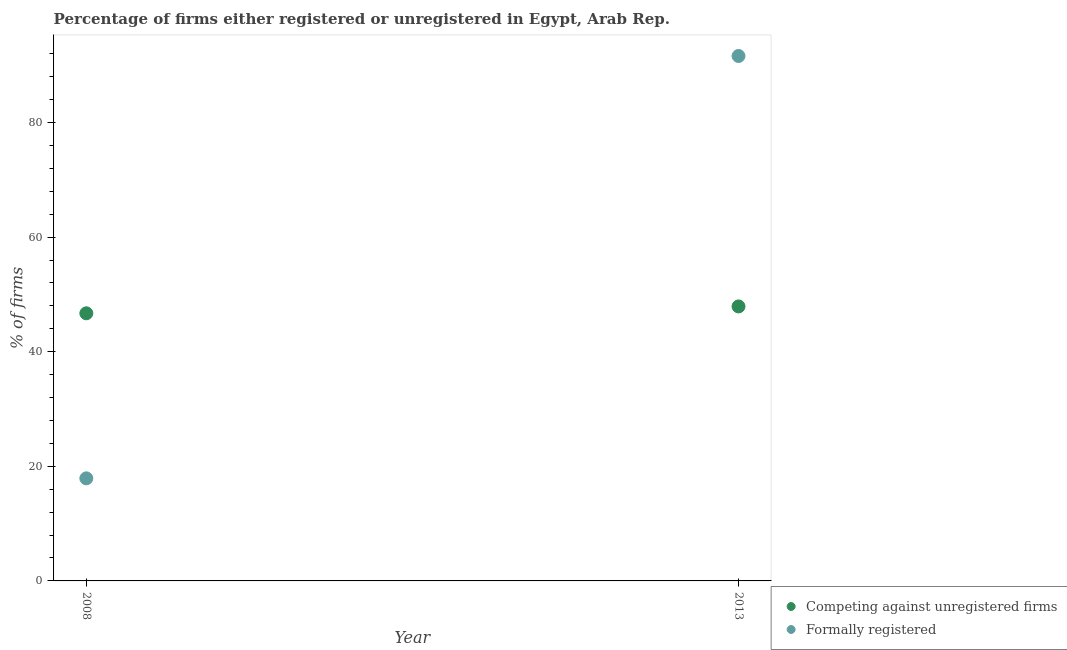Is the number of dotlines equal to the number of legend labels?
Offer a very short reply. Yes. What is the percentage of formally registered firms in 2013?
Your answer should be very brief. 91.6. Across all years, what is the maximum percentage of formally registered firms?
Provide a short and direct response. 91.6. Across all years, what is the minimum percentage of registered firms?
Give a very brief answer. 46.7. What is the total percentage of registered firms in the graph?
Your answer should be very brief. 94.6. What is the difference between the percentage of registered firms in 2008 and that in 2013?
Make the answer very short. -1.2. What is the difference between the percentage of registered firms in 2013 and the percentage of formally registered firms in 2008?
Provide a short and direct response. 30. What is the average percentage of formally registered firms per year?
Provide a short and direct response. 54.75. In the year 2013, what is the difference between the percentage of registered firms and percentage of formally registered firms?
Provide a short and direct response. -43.7. What is the ratio of the percentage of formally registered firms in 2008 to that in 2013?
Offer a terse response. 0.2. Is the percentage of formally registered firms strictly greater than the percentage of registered firms over the years?
Give a very brief answer. No. Is the percentage of registered firms strictly less than the percentage of formally registered firms over the years?
Make the answer very short. No. How many dotlines are there?
Your response must be concise. 2. What is the difference between two consecutive major ticks on the Y-axis?
Provide a short and direct response. 20. Does the graph contain any zero values?
Your answer should be compact. No. Where does the legend appear in the graph?
Offer a very short reply. Bottom right. How are the legend labels stacked?
Make the answer very short. Vertical. What is the title of the graph?
Offer a terse response. Percentage of firms either registered or unregistered in Egypt, Arab Rep. Does "Export" appear as one of the legend labels in the graph?
Your answer should be very brief. No. What is the label or title of the X-axis?
Provide a succinct answer. Year. What is the label or title of the Y-axis?
Offer a very short reply. % of firms. What is the % of firms in Competing against unregistered firms in 2008?
Offer a very short reply. 46.7. What is the % of firms in Competing against unregistered firms in 2013?
Provide a succinct answer. 47.9. What is the % of firms of Formally registered in 2013?
Give a very brief answer. 91.6. Across all years, what is the maximum % of firms in Competing against unregistered firms?
Offer a terse response. 47.9. Across all years, what is the maximum % of firms in Formally registered?
Your response must be concise. 91.6. Across all years, what is the minimum % of firms of Competing against unregistered firms?
Offer a very short reply. 46.7. Across all years, what is the minimum % of firms of Formally registered?
Your answer should be very brief. 17.9. What is the total % of firms of Competing against unregistered firms in the graph?
Provide a succinct answer. 94.6. What is the total % of firms in Formally registered in the graph?
Give a very brief answer. 109.5. What is the difference between the % of firms of Formally registered in 2008 and that in 2013?
Offer a very short reply. -73.7. What is the difference between the % of firms of Competing against unregistered firms in 2008 and the % of firms of Formally registered in 2013?
Offer a very short reply. -44.9. What is the average % of firms of Competing against unregistered firms per year?
Provide a succinct answer. 47.3. What is the average % of firms of Formally registered per year?
Offer a terse response. 54.75. In the year 2008, what is the difference between the % of firms of Competing against unregistered firms and % of firms of Formally registered?
Keep it short and to the point. 28.8. In the year 2013, what is the difference between the % of firms of Competing against unregistered firms and % of firms of Formally registered?
Ensure brevity in your answer.  -43.7. What is the ratio of the % of firms of Competing against unregistered firms in 2008 to that in 2013?
Offer a very short reply. 0.97. What is the ratio of the % of firms in Formally registered in 2008 to that in 2013?
Provide a succinct answer. 0.2. What is the difference between the highest and the second highest % of firms of Competing against unregistered firms?
Provide a succinct answer. 1.2. What is the difference between the highest and the second highest % of firms in Formally registered?
Ensure brevity in your answer.  73.7. What is the difference between the highest and the lowest % of firms in Competing against unregistered firms?
Your answer should be very brief. 1.2. What is the difference between the highest and the lowest % of firms of Formally registered?
Ensure brevity in your answer.  73.7. 